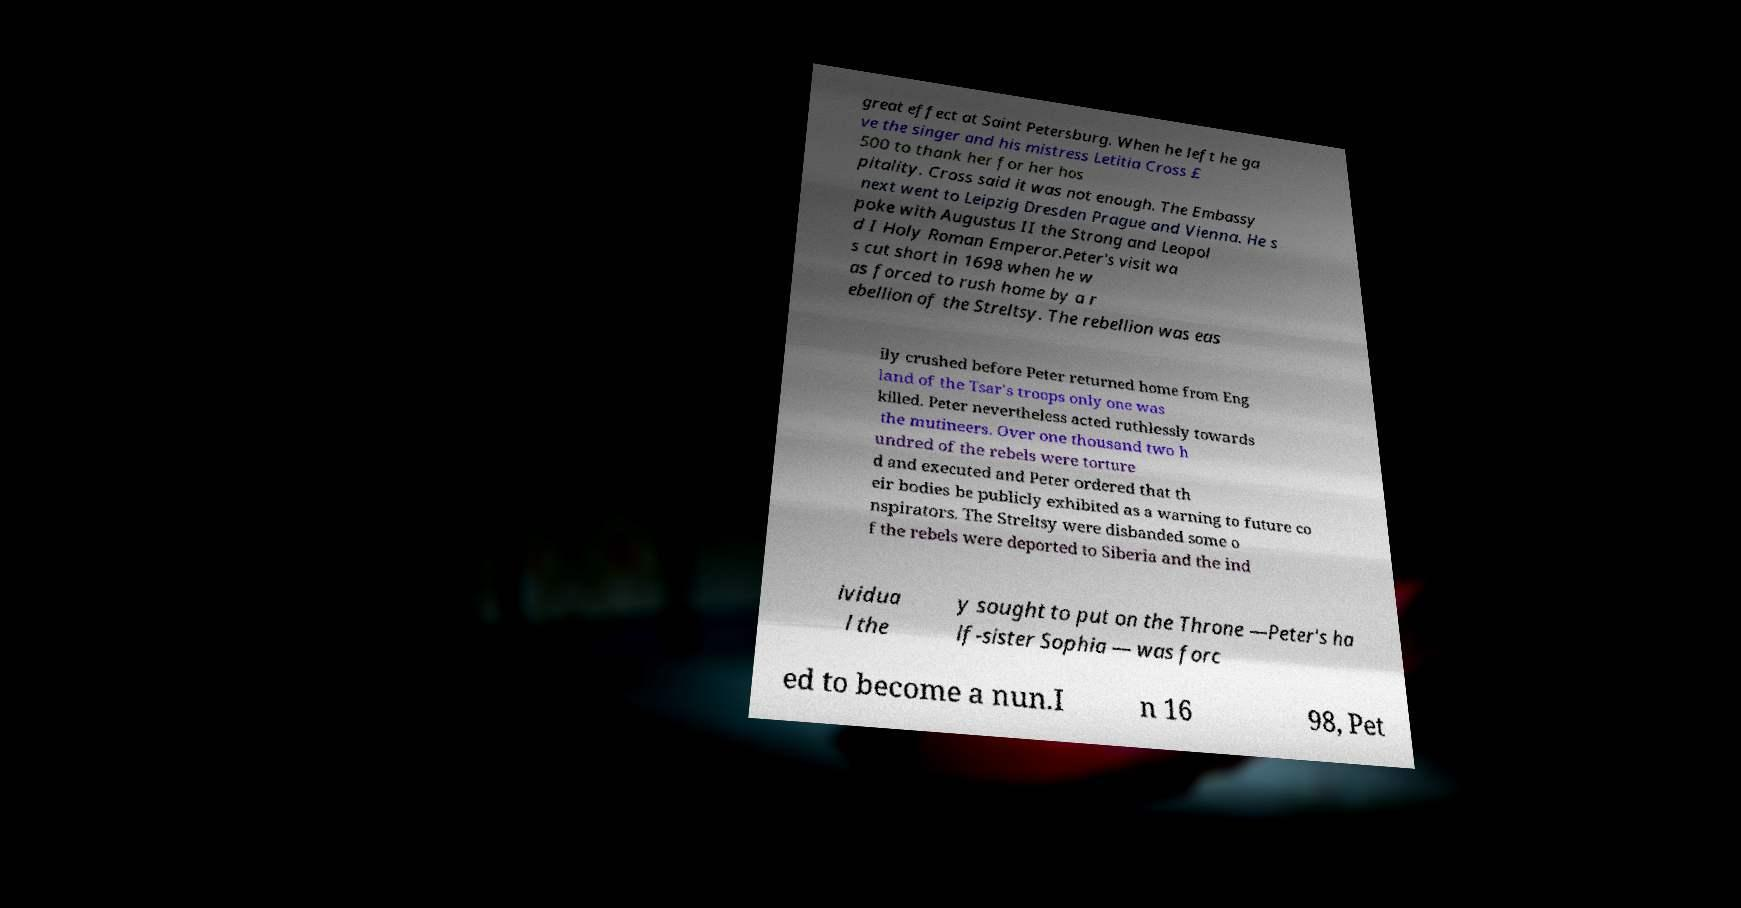What messages or text are displayed in this image? I need them in a readable, typed format. great effect at Saint Petersburg. When he left he ga ve the singer and his mistress Letitia Cross £ 500 to thank her for her hos pitality. Cross said it was not enough. The Embassy next went to Leipzig Dresden Prague and Vienna. He s poke with Augustus II the Strong and Leopol d I Holy Roman Emperor.Peter's visit wa s cut short in 1698 when he w as forced to rush home by a r ebellion of the Streltsy. The rebellion was eas ily crushed before Peter returned home from Eng land of the Tsar's troops only one was killed. Peter nevertheless acted ruthlessly towards the mutineers. Over one thousand two h undred of the rebels were torture d and executed and Peter ordered that th eir bodies be publicly exhibited as a warning to future co nspirators. The Streltsy were disbanded some o f the rebels were deported to Siberia and the ind ividua l the y sought to put on the Throne —Peter's ha lf-sister Sophia — was forc ed to become a nun.I n 16 98, Pet 